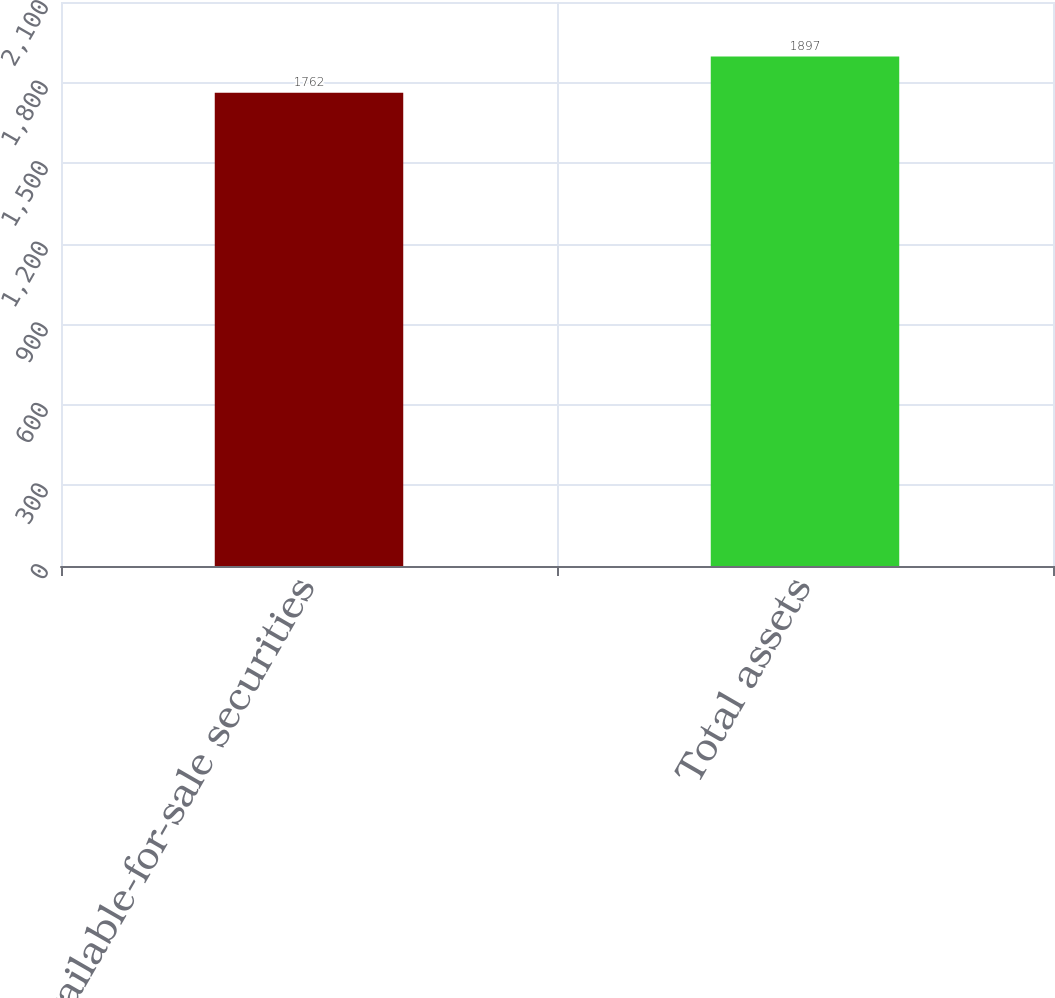Convert chart. <chart><loc_0><loc_0><loc_500><loc_500><bar_chart><fcel>Available-for-sale securities<fcel>Total assets<nl><fcel>1762<fcel>1897<nl></chart> 